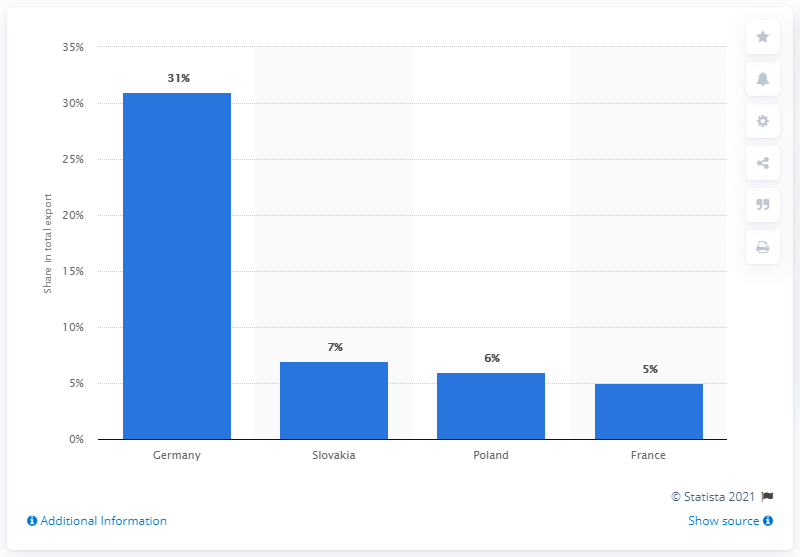Highlight a few significant elements in this photo. In 2019, Germany was the most significant export partner of the Czech Republic. 